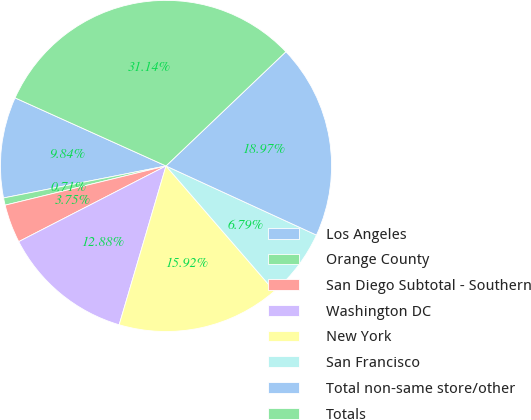Convert chart. <chart><loc_0><loc_0><loc_500><loc_500><pie_chart><fcel>Los Angeles<fcel>Orange County<fcel>San Diego Subtotal - Southern<fcel>Washington DC<fcel>New York<fcel>San Francisco<fcel>Total non-same store/other<fcel>Totals<nl><fcel>9.84%<fcel>0.71%<fcel>3.75%<fcel>12.88%<fcel>15.92%<fcel>6.79%<fcel>18.97%<fcel>31.14%<nl></chart> 